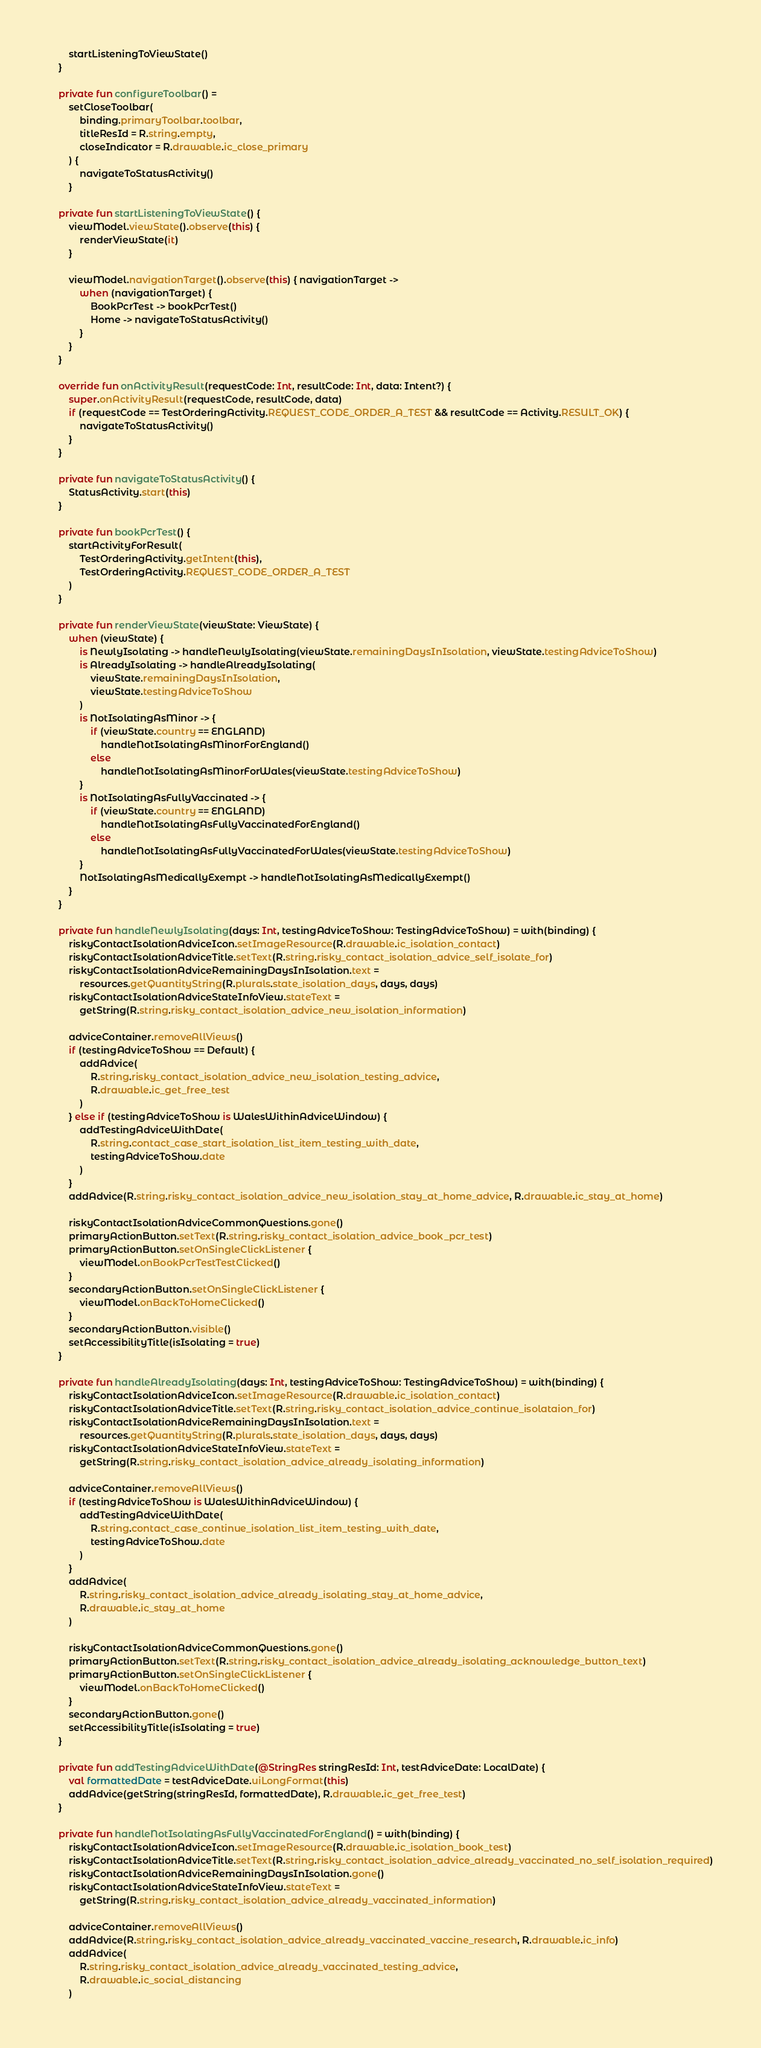<code> <loc_0><loc_0><loc_500><loc_500><_Kotlin_>
        startListeningToViewState()
    }

    private fun configureToolbar() =
        setCloseToolbar(
            binding.primaryToolbar.toolbar,
            titleResId = R.string.empty,
            closeIndicator = R.drawable.ic_close_primary
        ) {
            navigateToStatusActivity()
        }

    private fun startListeningToViewState() {
        viewModel.viewState().observe(this) {
            renderViewState(it)
        }

        viewModel.navigationTarget().observe(this) { navigationTarget ->
            when (navigationTarget) {
                BookPcrTest -> bookPcrTest()
                Home -> navigateToStatusActivity()
            }
        }
    }

    override fun onActivityResult(requestCode: Int, resultCode: Int, data: Intent?) {
        super.onActivityResult(requestCode, resultCode, data)
        if (requestCode == TestOrderingActivity.REQUEST_CODE_ORDER_A_TEST && resultCode == Activity.RESULT_OK) {
            navigateToStatusActivity()
        }
    }

    private fun navigateToStatusActivity() {
        StatusActivity.start(this)
    }

    private fun bookPcrTest() {
        startActivityForResult(
            TestOrderingActivity.getIntent(this),
            TestOrderingActivity.REQUEST_CODE_ORDER_A_TEST
        )
    }

    private fun renderViewState(viewState: ViewState) {
        when (viewState) {
            is NewlyIsolating -> handleNewlyIsolating(viewState.remainingDaysInIsolation, viewState.testingAdviceToShow)
            is AlreadyIsolating -> handleAlreadyIsolating(
                viewState.remainingDaysInIsolation,
                viewState.testingAdviceToShow
            )
            is NotIsolatingAsMinor -> {
                if (viewState.country == ENGLAND)
                    handleNotIsolatingAsMinorForEngland()
                else
                    handleNotIsolatingAsMinorForWales(viewState.testingAdviceToShow)
            }
            is NotIsolatingAsFullyVaccinated -> {
                if (viewState.country == ENGLAND)
                    handleNotIsolatingAsFullyVaccinatedForEngland()
                else
                    handleNotIsolatingAsFullyVaccinatedForWales(viewState.testingAdviceToShow)
            }
            NotIsolatingAsMedicallyExempt -> handleNotIsolatingAsMedicallyExempt()
        }
    }

    private fun handleNewlyIsolating(days: Int, testingAdviceToShow: TestingAdviceToShow) = with(binding) {
        riskyContactIsolationAdviceIcon.setImageResource(R.drawable.ic_isolation_contact)
        riskyContactIsolationAdviceTitle.setText(R.string.risky_contact_isolation_advice_self_isolate_for)
        riskyContactIsolationAdviceRemainingDaysInIsolation.text =
            resources.getQuantityString(R.plurals.state_isolation_days, days, days)
        riskyContactIsolationAdviceStateInfoView.stateText =
            getString(R.string.risky_contact_isolation_advice_new_isolation_information)

        adviceContainer.removeAllViews()
        if (testingAdviceToShow == Default) {
            addAdvice(
                R.string.risky_contact_isolation_advice_new_isolation_testing_advice,
                R.drawable.ic_get_free_test
            )
        } else if (testingAdviceToShow is WalesWithinAdviceWindow) {
            addTestingAdviceWithDate(
                R.string.contact_case_start_isolation_list_item_testing_with_date,
                testingAdviceToShow.date
            )
        }
        addAdvice(R.string.risky_contact_isolation_advice_new_isolation_stay_at_home_advice, R.drawable.ic_stay_at_home)

        riskyContactIsolationAdviceCommonQuestions.gone()
        primaryActionButton.setText(R.string.risky_contact_isolation_advice_book_pcr_test)
        primaryActionButton.setOnSingleClickListener {
            viewModel.onBookPcrTestTestClicked()
        }
        secondaryActionButton.setOnSingleClickListener {
            viewModel.onBackToHomeClicked()
        }
        secondaryActionButton.visible()
        setAccessibilityTitle(isIsolating = true)
    }

    private fun handleAlreadyIsolating(days: Int, testingAdviceToShow: TestingAdviceToShow) = with(binding) {
        riskyContactIsolationAdviceIcon.setImageResource(R.drawable.ic_isolation_contact)
        riskyContactIsolationAdviceTitle.setText(R.string.risky_contact_isolation_advice_continue_isolataion_for)
        riskyContactIsolationAdviceRemainingDaysInIsolation.text =
            resources.getQuantityString(R.plurals.state_isolation_days, days, days)
        riskyContactIsolationAdviceStateInfoView.stateText =
            getString(R.string.risky_contact_isolation_advice_already_isolating_information)

        adviceContainer.removeAllViews()
        if (testingAdviceToShow is WalesWithinAdviceWindow) {
            addTestingAdviceWithDate(
                R.string.contact_case_continue_isolation_list_item_testing_with_date,
                testingAdviceToShow.date
            )
        }
        addAdvice(
            R.string.risky_contact_isolation_advice_already_isolating_stay_at_home_advice,
            R.drawable.ic_stay_at_home
        )

        riskyContactIsolationAdviceCommonQuestions.gone()
        primaryActionButton.setText(R.string.risky_contact_isolation_advice_already_isolating_acknowledge_button_text)
        primaryActionButton.setOnSingleClickListener {
            viewModel.onBackToHomeClicked()
        }
        secondaryActionButton.gone()
        setAccessibilityTitle(isIsolating = true)
    }

    private fun addTestingAdviceWithDate(@StringRes stringResId: Int, testAdviceDate: LocalDate) {
        val formattedDate = testAdviceDate.uiLongFormat(this)
        addAdvice(getString(stringResId, formattedDate), R.drawable.ic_get_free_test)
    }

    private fun handleNotIsolatingAsFullyVaccinatedForEngland() = with(binding) {
        riskyContactIsolationAdviceIcon.setImageResource(R.drawable.ic_isolation_book_test)
        riskyContactIsolationAdviceTitle.setText(R.string.risky_contact_isolation_advice_already_vaccinated_no_self_isolation_required)
        riskyContactIsolationAdviceRemainingDaysInIsolation.gone()
        riskyContactIsolationAdviceStateInfoView.stateText =
            getString(R.string.risky_contact_isolation_advice_already_vaccinated_information)

        adviceContainer.removeAllViews()
        addAdvice(R.string.risky_contact_isolation_advice_already_vaccinated_vaccine_research, R.drawable.ic_info)
        addAdvice(
            R.string.risky_contact_isolation_advice_already_vaccinated_testing_advice,
            R.drawable.ic_social_distancing
        )
</code> 